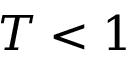<formula> <loc_0><loc_0><loc_500><loc_500>T < 1</formula> 